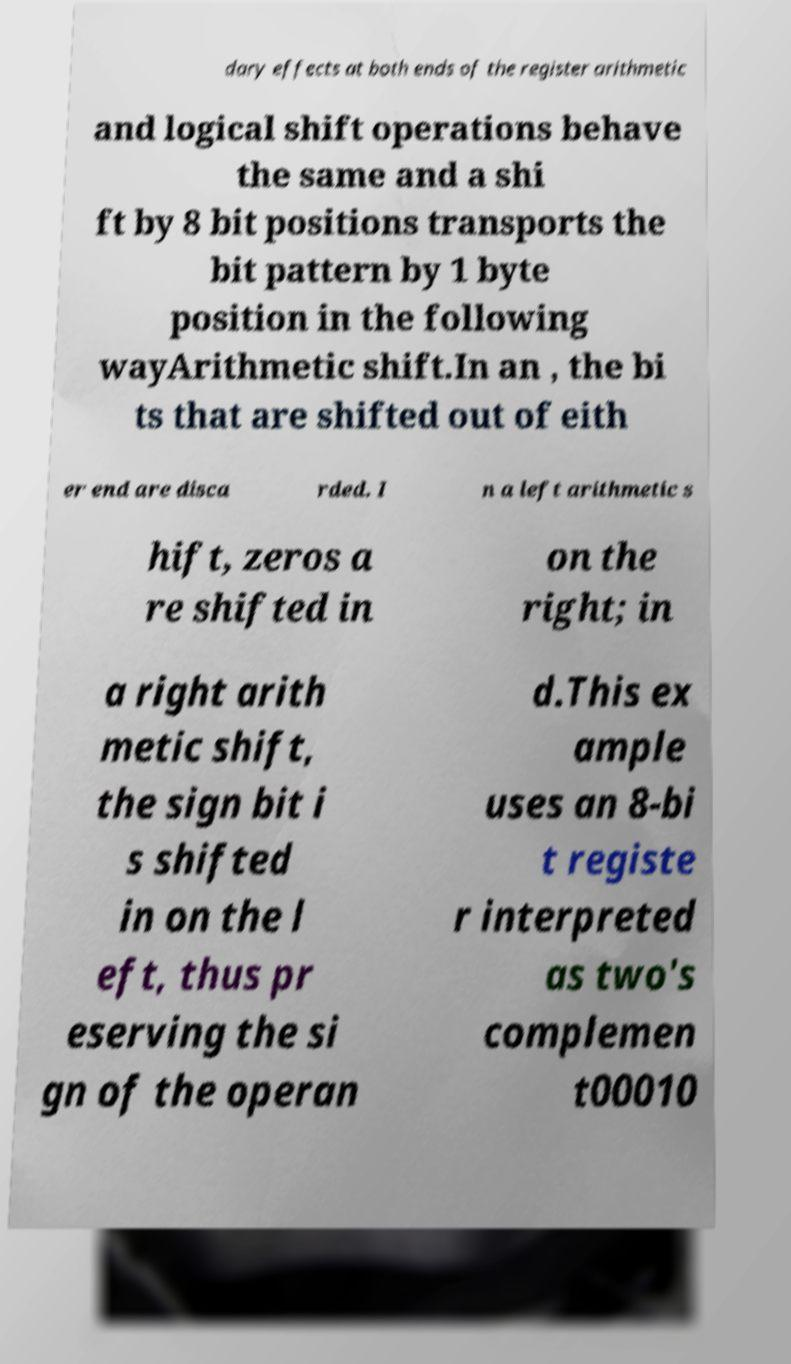Can you read and provide the text displayed in the image?This photo seems to have some interesting text. Can you extract and type it out for me? dary effects at both ends of the register arithmetic and logical shift operations behave the same and a shi ft by 8 bit positions transports the bit pattern by 1 byte position in the following wayArithmetic shift.In an , the bi ts that are shifted out of eith er end are disca rded. I n a left arithmetic s hift, zeros a re shifted in on the right; in a right arith metic shift, the sign bit i s shifted in on the l eft, thus pr eserving the si gn of the operan d.This ex ample uses an 8-bi t registe r interpreted as two's complemen t00010 